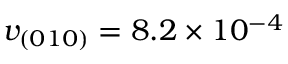Convert formula to latex. <formula><loc_0><loc_0><loc_500><loc_500>v _ { ( 0 1 0 ) } = 8 . 2 \times 1 0 ^ { - 4 }</formula> 